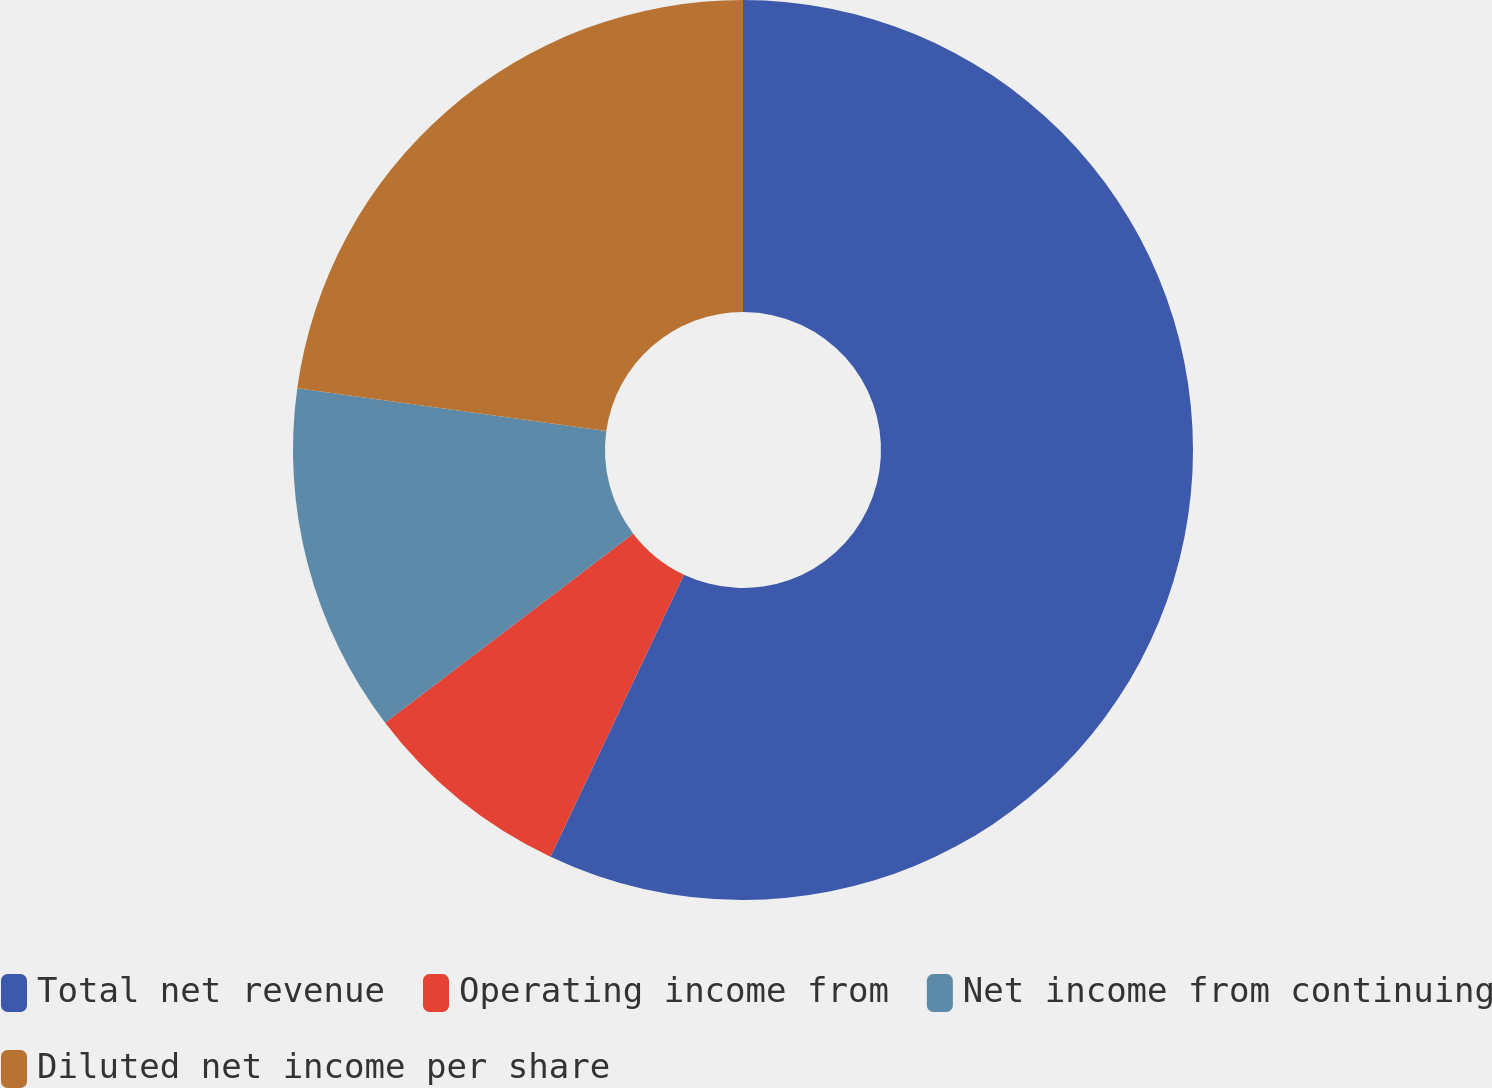Convert chart to OTSL. <chart><loc_0><loc_0><loc_500><loc_500><pie_chart><fcel>Total net revenue<fcel>Operating income from<fcel>Net income from continuing<fcel>Diluted net income per share<nl><fcel>57.03%<fcel>7.6%<fcel>12.55%<fcel>22.81%<nl></chart> 